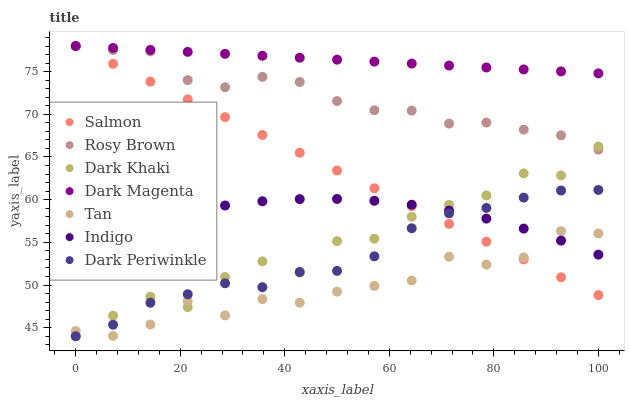Does Tan have the minimum area under the curve?
Answer yes or no. Yes. Does Dark Magenta have the maximum area under the curve?
Answer yes or no. Yes. Does Rosy Brown have the minimum area under the curve?
Answer yes or no. No. Does Rosy Brown have the maximum area under the curve?
Answer yes or no. No. Is Salmon the smoothest?
Answer yes or no. Yes. Is Dark Khaki the roughest?
Answer yes or no. Yes. Is Dark Magenta the smoothest?
Answer yes or no. No. Is Dark Magenta the roughest?
Answer yes or no. No. Does Dark Khaki have the lowest value?
Answer yes or no. Yes. Does Rosy Brown have the lowest value?
Answer yes or no. No. Does Salmon have the highest value?
Answer yes or no. Yes. Does Dark Khaki have the highest value?
Answer yes or no. No. Is Dark Khaki less than Dark Magenta?
Answer yes or no. Yes. Is Rosy Brown greater than Dark Periwinkle?
Answer yes or no. Yes. Does Salmon intersect Tan?
Answer yes or no. Yes. Is Salmon less than Tan?
Answer yes or no. No. Is Salmon greater than Tan?
Answer yes or no. No. Does Dark Khaki intersect Dark Magenta?
Answer yes or no. No. 